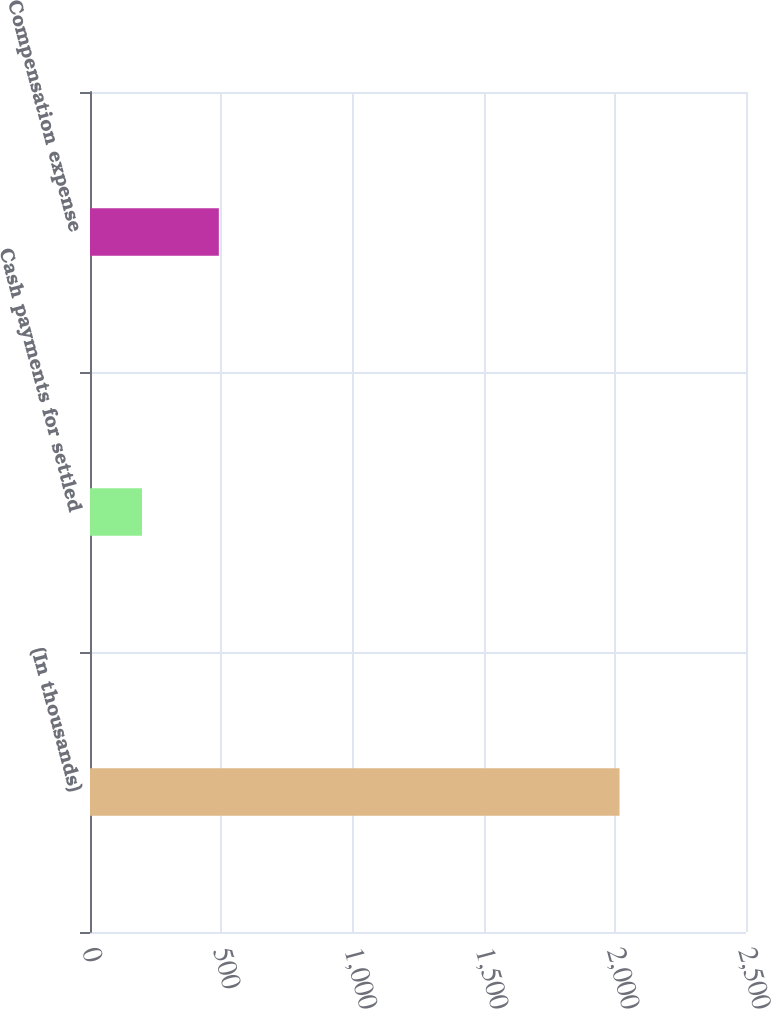Convert chart. <chart><loc_0><loc_0><loc_500><loc_500><bar_chart><fcel>(In thousands)<fcel>Cash payments for settled<fcel>Compensation expense<nl><fcel>2018<fcel>198<fcel>491<nl></chart> 